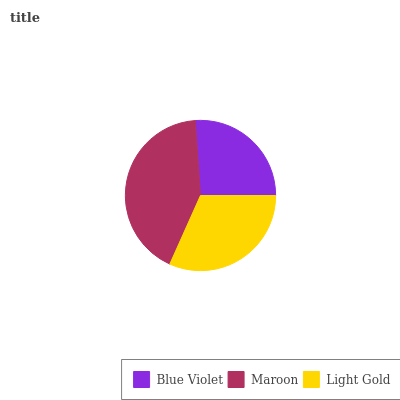Is Blue Violet the minimum?
Answer yes or no. Yes. Is Maroon the maximum?
Answer yes or no. Yes. Is Light Gold the minimum?
Answer yes or no. No. Is Light Gold the maximum?
Answer yes or no. No. Is Maroon greater than Light Gold?
Answer yes or no. Yes. Is Light Gold less than Maroon?
Answer yes or no. Yes. Is Light Gold greater than Maroon?
Answer yes or no. No. Is Maroon less than Light Gold?
Answer yes or no. No. Is Light Gold the high median?
Answer yes or no. Yes. Is Light Gold the low median?
Answer yes or no. Yes. Is Maroon the high median?
Answer yes or no. No. Is Maroon the low median?
Answer yes or no. No. 